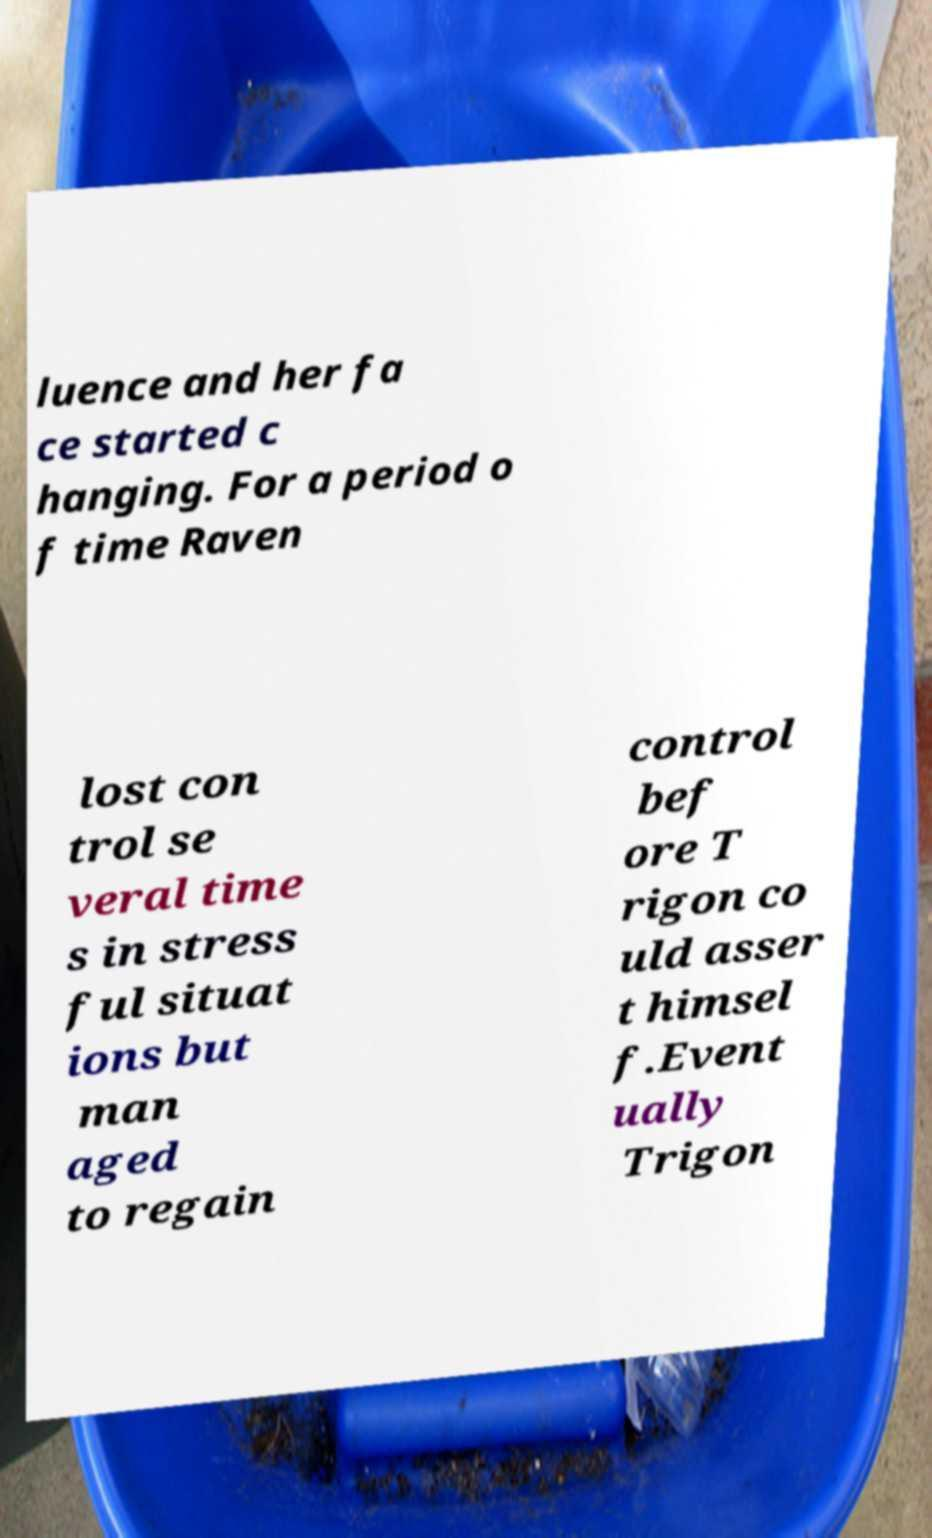Can you read and provide the text displayed in the image?This photo seems to have some interesting text. Can you extract and type it out for me? luence and her fa ce started c hanging. For a period o f time Raven lost con trol se veral time s in stress ful situat ions but man aged to regain control bef ore T rigon co uld asser t himsel f.Event ually Trigon 